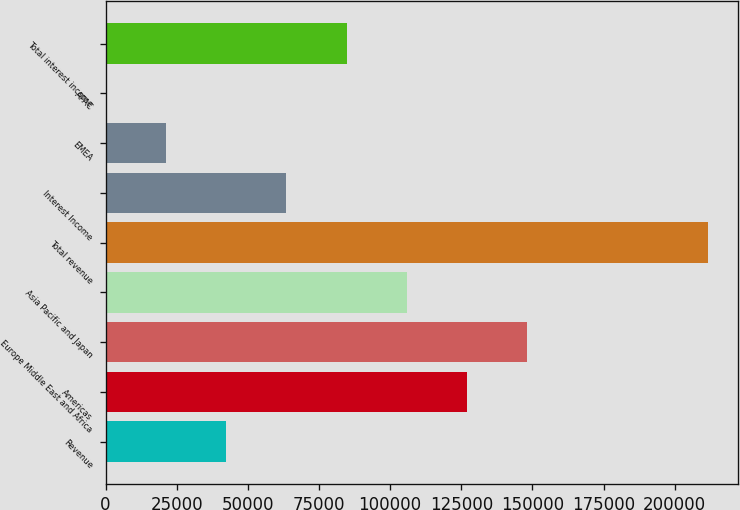Convert chart. <chart><loc_0><loc_0><loc_500><loc_500><bar_chart><fcel>Revenue<fcel>Americas<fcel>Europe Middle East and Africa<fcel>Asia Pacific and Japan<fcel>Total revenue<fcel>Interest Income<fcel>EMEA<fcel>APAC<fcel>Total interest income<nl><fcel>42360.6<fcel>127076<fcel>148255<fcel>105897<fcel>211791<fcel>63539.4<fcel>21181.8<fcel>3<fcel>84718.2<nl></chart> 